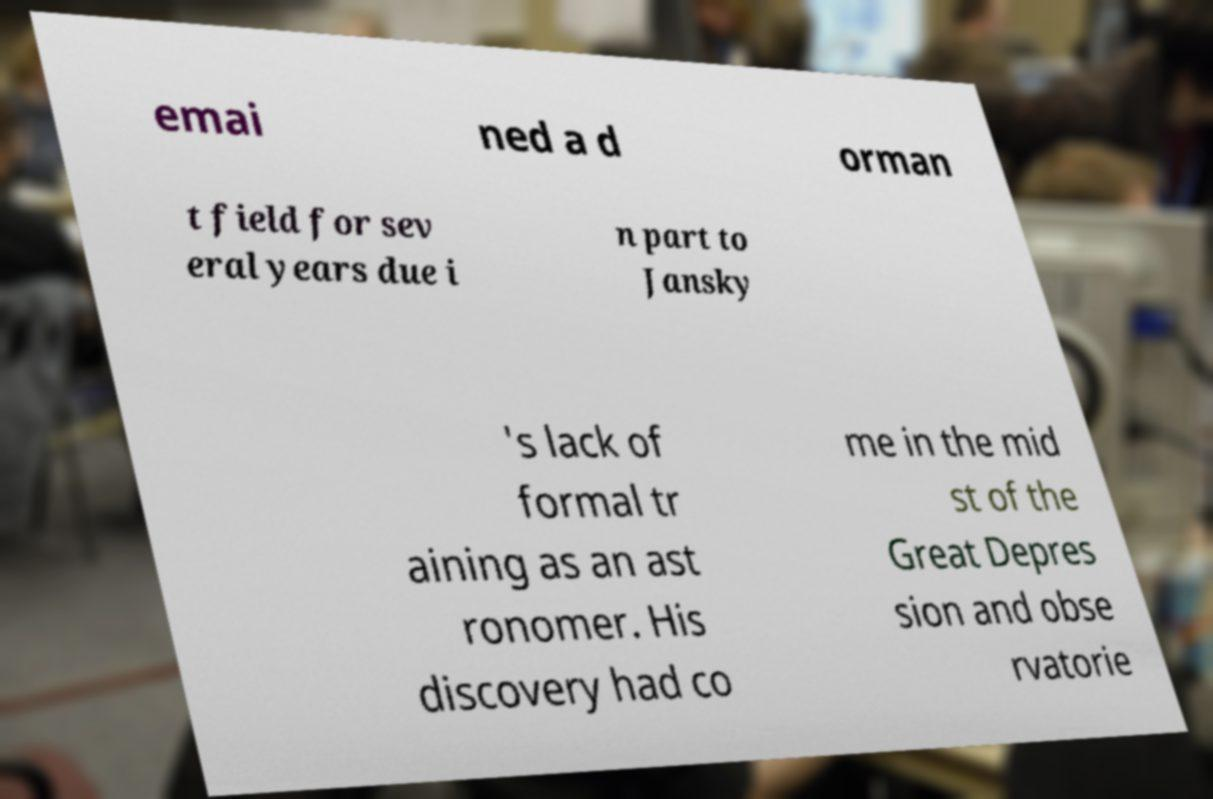For documentation purposes, I need the text within this image transcribed. Could you provide that? emai ned a d orman t field for sev eral years due i n part to Jansky 's lack of formal tr aining as an ast ronomer. His discovery had co me in the mid st of the Great Depres sion and obse rvatorie 